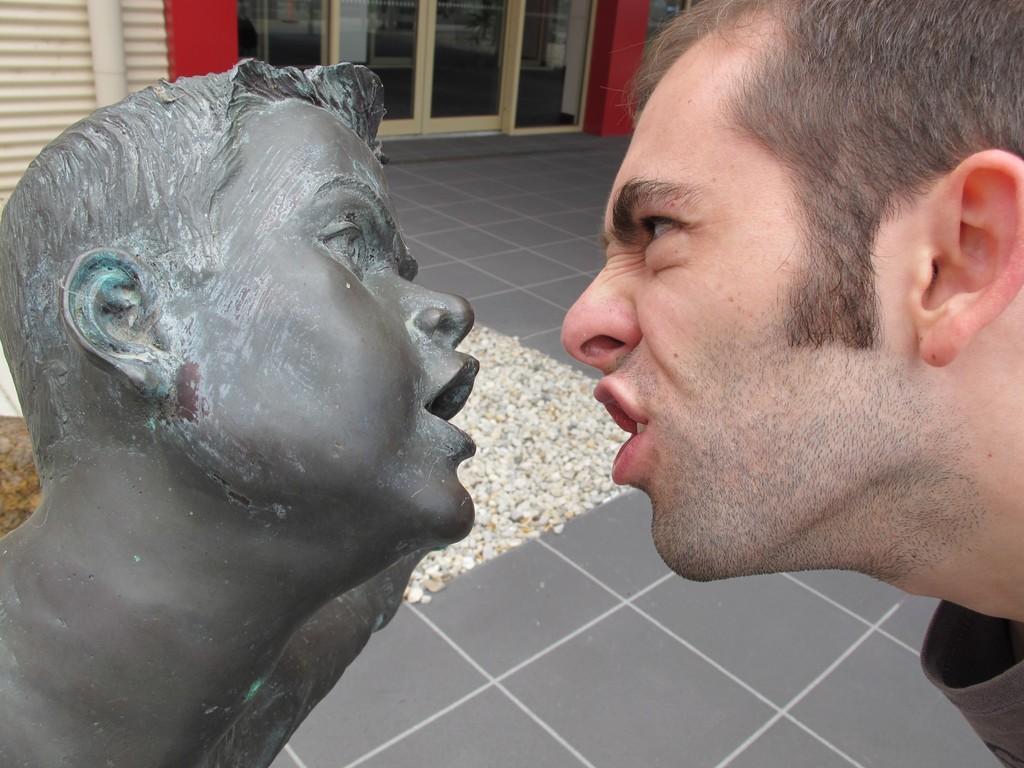Could you give a brief overview of what you see in this image? In this image we can see a person, there is a statue, there are stones, also we can see the wall, and doors. 